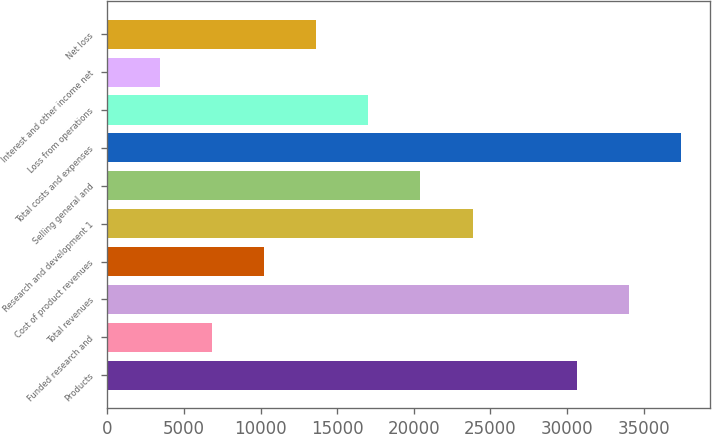<chart> <loc_0><loc_0><loc_500><loc_500><bar_chart><fcel>Products<fcel>Funded research and<fcel>Total revenues<fcel>Cost of product revenues<fcel>Research and development 1<fcel>Selling general and<fcel>Total costs and expenses<fcel>Loss from operations<fcel>Interest and other income net<fcel>Net loss<nl><fcel>30658.5<fcel>6813.44<fcel>34065<fcel>10219.9<fcel>23845.6<fcel>20439.2<fcel>37471.4<fcel>17032.8<fcel>3407<fcel>13626.3<nl></chart> 